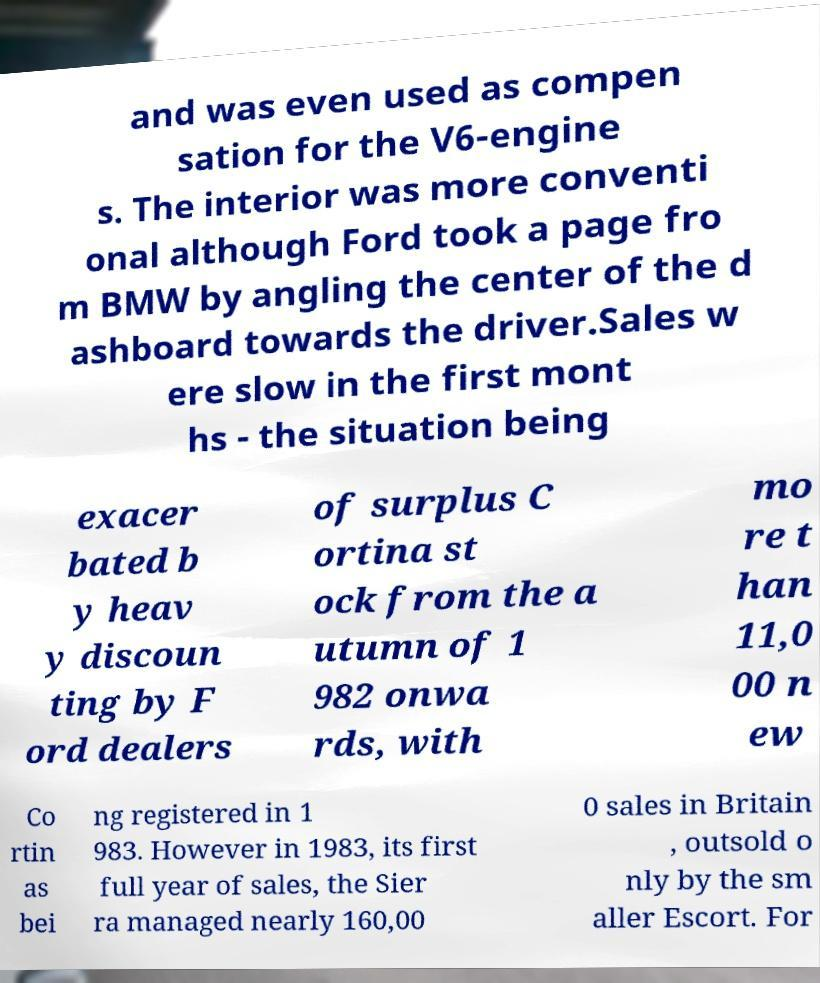Could you assist in decoding the text presented in this image and type it out clearly? and was even used as compen sation for the V6-engine s. The interior was more conventi onal although Ford took a page fro m BMW by angling the center of the d ashboard towards the driver.Sales w ere slow in the first mont hs - the situation being exacer bated b y heav y discoun ting by F ord dealers of surplus C ortina st ock from the a utumn of 1 982 onwa rds, with mo re t han 11,0 00 n ew Co rtin as bei ng registered in 1 983. However in 1983, its first full year of sales, the Sier ra managed nearly 160,00 0 sales in Britain , outsold o nly by the sm aller Escort. For 